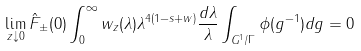Convert formula to latex. <formula><loc_0><loc_0><loc_500><loc_500>\lim _ { z \downarrow 0 } \hat { F } _ { \pm } ( 0 ) \int _ { 0 } ^ { \infty } w _ { z } ( \lambda ) \lambda ^ { 4 ( 1 - s + w ) } \frac { d \lambda } { \lambda } \int _ { G ^ { 1 } / \Gamma } \phi ( g ^ { - 1 } ) d g = 0</formula> 